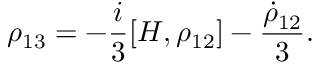<formula> <loc_0><loc_0><loc_500><loc_500>\rho _ { 1 3 } = - \frac { i } { 3 } [ H , \rho _ { 1 2 } ] - \frac { \dot { \rho } _ { 1 2 } } { 3 } .</formula> 